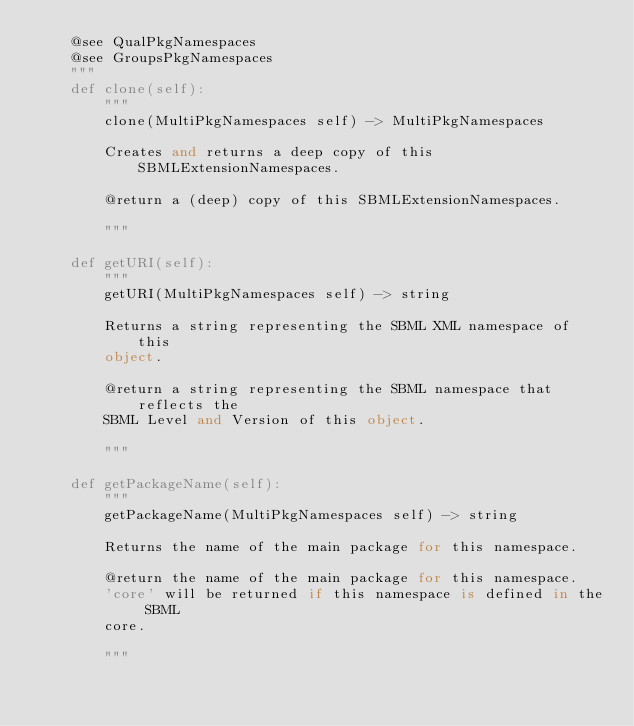<code> <loc_0><loc_0><loc_500><loc_500><_Python_>    @see QualPkgNamespaces
    @see GroupsPkgNamespaces
    """
    def clone(self):
        """
        clone(MultiPkgNamespaces self) -> MultiPkgNamespaces

        Creates and returns a deep copy of this SBMLExtensionNamespaces.

        @return a (deep) copy of this SBMLExtensionNamespaces.

        """

    def getURI(self):
        """
        getURI(MultiPkgNamespaces self) -> string

        Returns a string representing the SBML XML namespace of this
        object.

        @return a string representing the SBML namespace that reflects the
        SBML Level and Version of this object.

        """

    def getPackageName(self):
        """
        getPackageName(MultiPkgNamespaces self) -> string

        Returns the name of the main package for this namespace.

        @return the name of the main package for this namespace.
        'core' will be returned if this namespace is defined in the SBML 
        core.

        """
</code> 